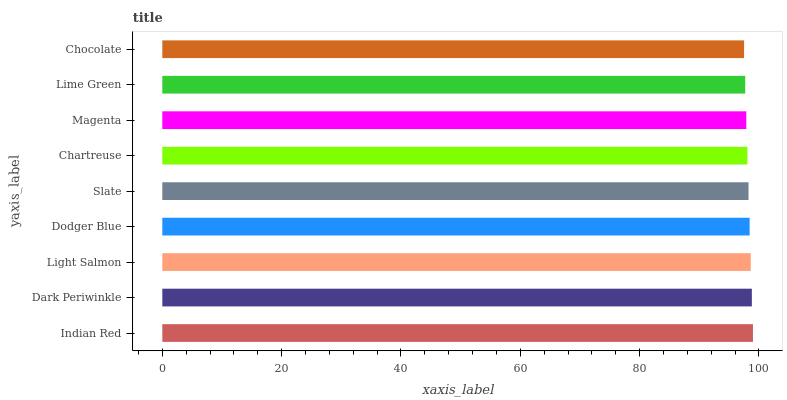Is Chocolate the minimum?
Answer yes or no. Yes. Is Indian Red the maximum?
Answer yes or no. Yes. Is Dark Periwinkle the minimum?
Answer yes or no. No. Is Dark Periwinkle the maximum?
Answer yes or no. No. Is Indian Red greater than Dark Periwinkle?
Answer yes or no. Yes. Is Dark Periwinkle less than Indian Red?
Answer yes or no. Yes. Is Dark Periwinkle greater than Indian Red?
Answer yes or no. No. Is Indian Red less than Dark Periwinkle?
Answer yes or no. No. Is Slate the high median?
Answer yes or no. Yes. Is Slate the low median?
Answer yes or no. Yes. Is Magenta the high median?
Answer yes or no. No. Is Chocolate the low median?
Answer yes or no. No. 